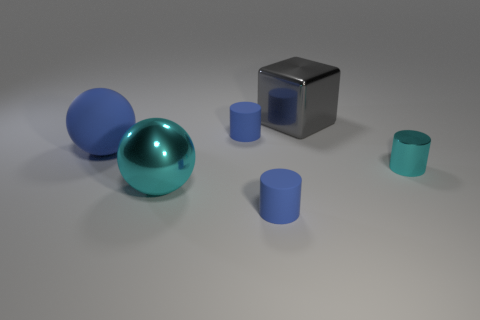Add 4 small gray blocks. How many objects exist? 10 Subtract all spheres. How many objects are left? 4 Add 4 big cyan metallic balls. How many big cyan metallic balls exist? 5 Subtract 0 brown cubes. How many objects are left? 6 Subtract all big gray shiny cylinders. Subtract all metallic cylinders. How many objects are left? 5 Add 5 large gray shiny things. How many large gray shiny things are left? 6 